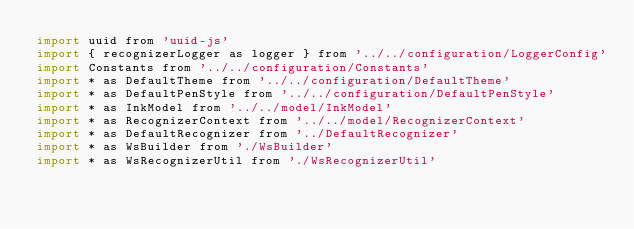Convert code to text. <code><loc_0><loc_0><loc_500><loc_500><_JavaScript_>import uuid from 'uuid-js'
import { recognizerLogger as logger } from '../../configuration/LoggerConfig'
import Constants from '../../configuration/Constants'
import * as DefaultTheme from '../../configuration/DefaultTheme'
import * as DefaultPenStyle from '../../configuration/DefaultPenStyle'
import * as InkModel from '../../model/InkModel'
import * as RecognizerContext from '../../model/RecognizerContext'
import * as DefaultRecognizer from '../DefaultRecognizer'
import * as WsBuilder from './WsBuilder'
import * as WsRecognizerUtil from './WsRecognizerUtil'</code> 